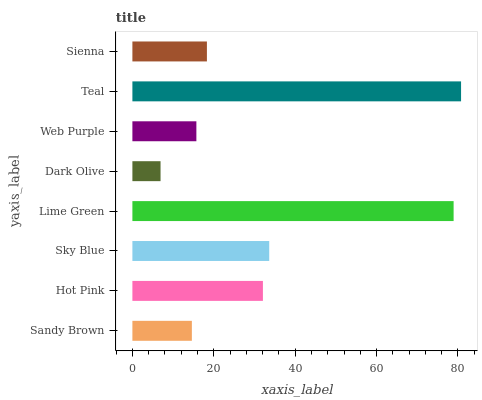Is Dark Olive the minimum?
Answer yes or no. Yes. Is Teal the maximum?
Answer yes or no. Yes. Is Hot Pink the minimum?
Answer yes or no. No. Is Hot Pink the maximum?
Answer yes or no. No. Is Hot Pink greater than Sandy Brown?
Answer yes or no. Yes. Is Sandy Brown less than Hot Pink?
Answer yes or no. Yes. Is Sandy Brown greater than Hot Pink?
Answer yes or no. No. Is Hot Pink less than Sandy Brown?
Answer yes or no. No. Is Hot Pink the high median?
Answer yes or no. Yes. Is Sienna the low median?
Answer yes or no. Yes. Is Sandy Brown the high median?
Answer yes or no. No. Is Teal the low median?
Answer yes or no. No. 